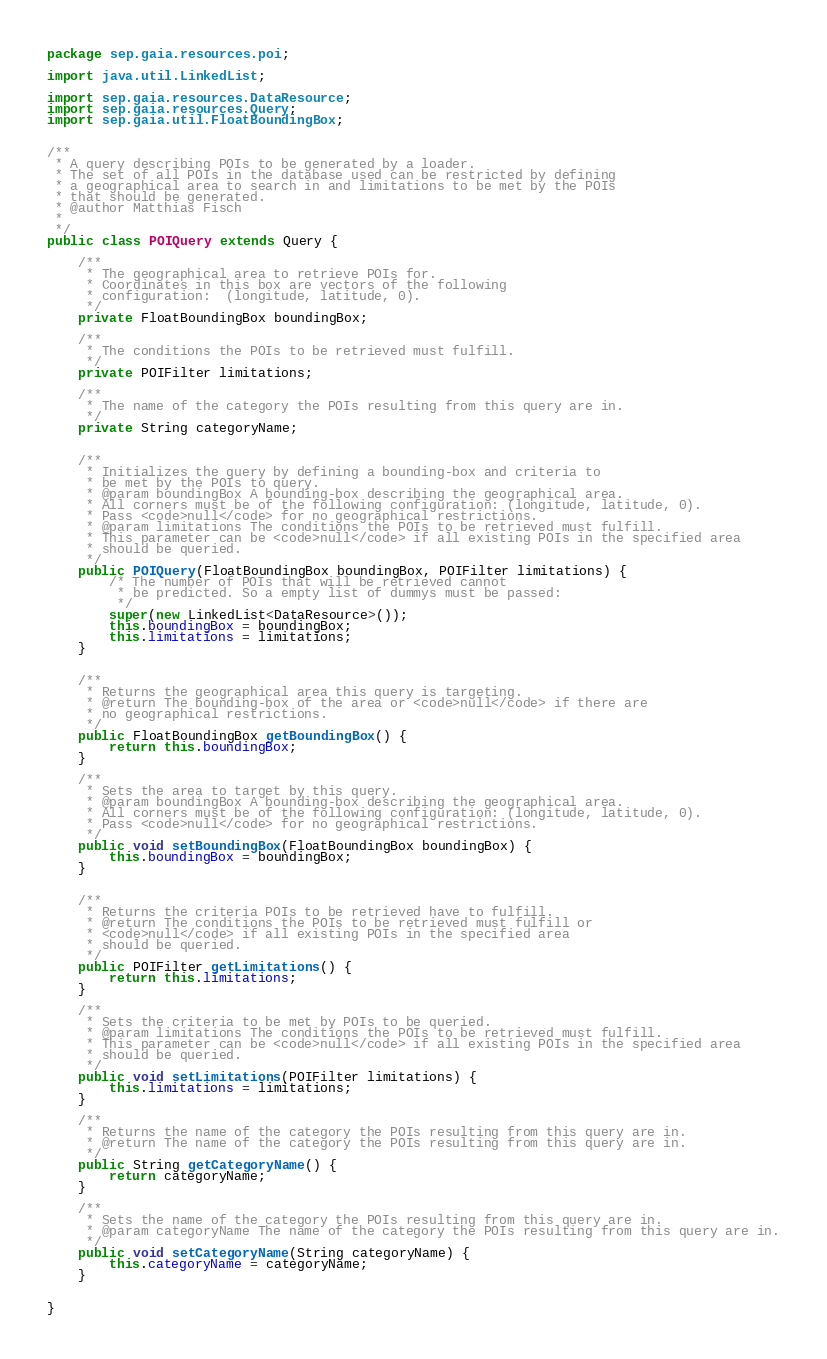Convert code to text. <code><loc_0><loc_0><loc_500><loc_500><_Java_>package sep.gaia.resources.poi;

import java.util.LinkedList;

import sep.gaia.resources.DataResource;
import sep.gaia.resources.Query;
import sep.gaia.util.FloatBoundingBox;


/**
 * A query describing POIs to be generated by a loader.
 * The set of all POIs in the database used can be restricted by defining
 * a geographical area to search in and limitations to be met by the POIs
 * that should be generated.
 * @author Matthias Fisch
 *
 */
public class POIQuery extends Query {

	/**
	 * The geographical area to retrieve POIs for.
	 * Coordinates in this box are vectors of the following
	 * configuration:  (longitude, latitude, 0).
	 */
	private FloatBoundingBox boundingBox;
	
	/**
	 * The conditions the POIs to be retrieved must fulfill.
	 */
	private POIFilter limitations;
	
	/**
	 * The name of the category the POIs resulting from this query are in.
	 */
	private String categoryName;
	
	
	/**
	 * Initializes the query by defining a bounding-box and criteria to
	 * be met by the POIs to query.
	 * @param boundingBox A bounding-box describing the geographical area.
	 * All corners must be of the following configuration: (longitude, latitude, 0).
	 * Pass <code>null</code> for no geographical restrictions.
	 * @param limitations The conditions the POIs to be retrieved must fulfill.
	 * This parameter can be <code>null</code> if all existing POIs in the specified area
	 * should be queried.
	 */
	public POIQuery(FloatBoundingBox boundingBox, POIFilter limitations) {
		/* The number of POIs that will be retrieved cannot
		 * be predicted. So a empty list of dummys must be passed:
		 */
		super(new LinkedList<DataResource>());
		this.boundingBox = boundingBox;
		this.limitations = limitations;
	}


	/**
	 * Returns the geographical area this query is targeting.
	 * @return The bounding-box of the area or <code>null</code> if there are
	 * no geographical restrictions.
	 */
	public FloatBoundingBox getBoundingBox() {
		return this.boundingBox;
	}

	/**
	 * Sets the area to target by this query.
	 * @param boundingBox A bounding-box describing the geographical area.
	 * All corners must be of the following configuration: (longitude, latitude, 0).
	 * Pass <code>null</code> for no geographical restrictions.
	 */
	public void setBoundingBox(FloatBoundingBox boundingBox) {
		this.boundingBox = boundingBox;
	}


	/**
	 * Returns the criteria POIs to be retrieved have to fulfill.
	 * @return The conditions the POIs to be retrieved must fulfill or
	 * <code>null</code> if all existing POIs in the specified area
	 * should be queried.
	 */
	public POIFilter getLimitations() {
		return this.limitations;
	}

	/**
	 * Sets the criteria to be met by POIs to be queried.
	 * @param limitations The conditions the POIs to be retrieved must fulfill.
	 * This parameter can be <code>null</code> if all existing POIs in the specified area
	 * should be queried.
	 */
	public void setLimitations(POIFilter limitations) {
		this.limitations = limitations;
	}

	/**
	 * Returns the name of the category the POIs resulting from this query are in.
	 * @return The name of the category the POIs resulting from this query are in.
	 */
	public String getCategoryName() {
		return categoryName;
	}

	/**
	 * Sets the name of the category the POIs resulting from this query are in.
	 * @param categoryName The name of the category the POIs resulting from this query are in.
	 */
	public void setCategoryName(String categoryName) {
		this.categoryName = categoryName;
	}
	
	
}
</code> 